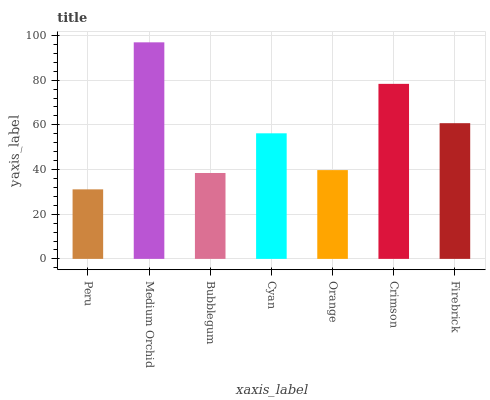Is Peru the minimum?
Answer yes or no. Yes. Is Medium Orchid the maximum?
Answer yes or no. Yes. Is Bubblegum the minimum?
Answer yes or no. No. Is Bubblegum the maximum?
Answer yes or no. No. Is Medium Orchid greater than Bubblegum?
Answer yes or no. Yes. Is Bubblegum less than Medium Orchid?
Answer yes or no. Yes. Is Bubblegum greater than Medium Orchid?
Answer yes or no. No. Is Medium Orchid less than Bubblegum?
Answer yes or no. No. Is Cyan the high median?
Answer yes or no. Yes. Is Cyan the low median?
Answer yes or no. Yes. Is Firebrick the high median?
Answer yes or no. No. Is Orange the low median?
Answer yes or no. No. 